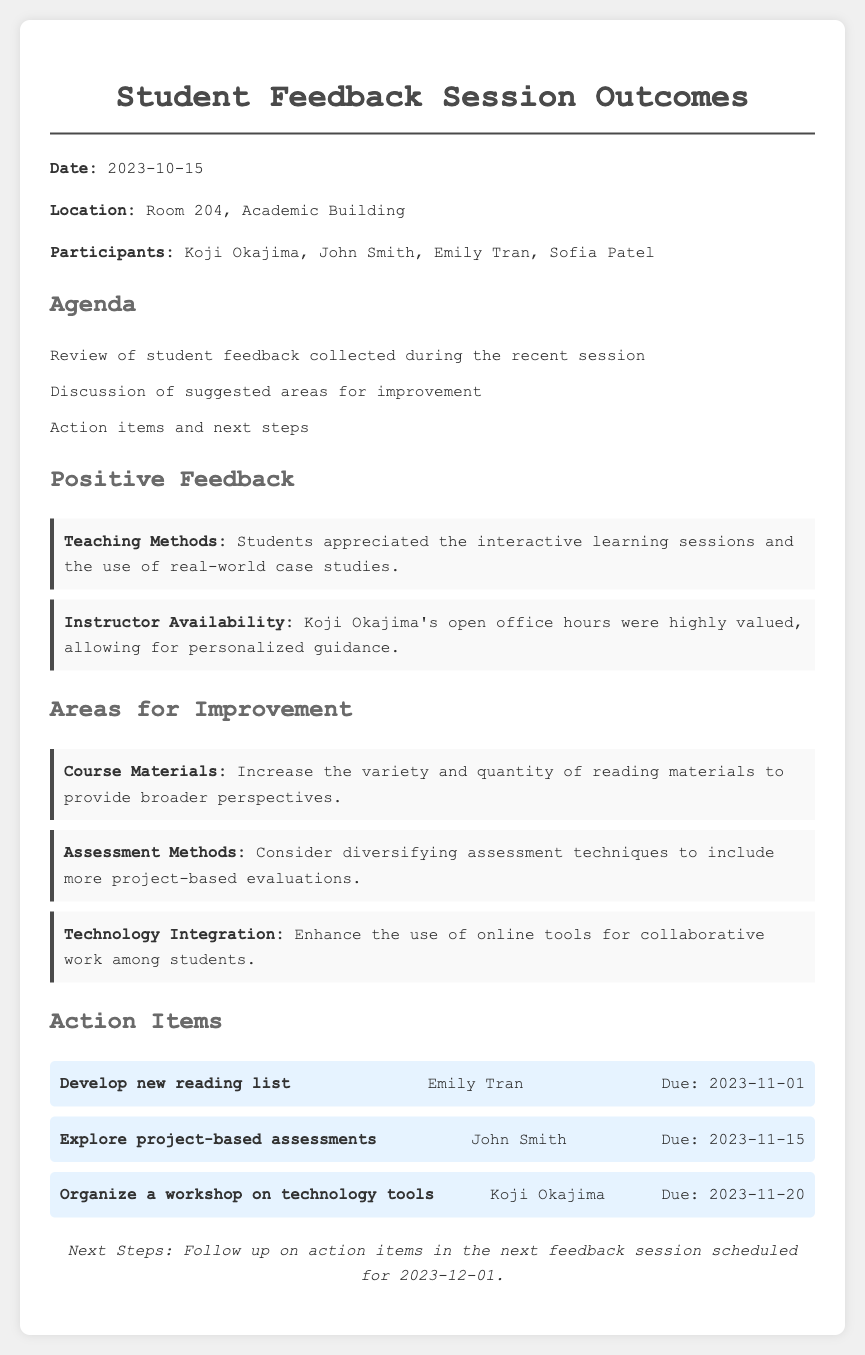What date was the feedback session held? The date of the feedback session is directly mentioned in the document.
Answer: 2023-10-15 Who is responsible for developing a new reading list? The document specifies the individual assigned to develop a new reading list within the action items section.
Answer: Emily Tran What is one area for improvement suggested by students? The document lists multiple areas for improvement; the question seeks to identify one of them.
Answer: Course Materials What is the due date for exploring project-based assessments? The deadlines for the action items are detailed in the document, with specific due dates provided.
Answer: 2023-11-15 How many participants attended the session? The document lists the participants present at the session, which provides the needed count.
Answer: Four What specific teaching method was appreciated by students? The feedback highlights positive aspects regarding teaching methods in the document.
Answer: Interactive learning sessions What workshop is Koji Okajima tasked with organizing? The action items include specific tasks assigned to individuals, including one for Koji Okajima.
Answer: Workshop on technology tools When is the next feedback session scheduled? The document concludes with the next steps, including the date for the upcoming feedback session.
Answer: 2023-12-01 